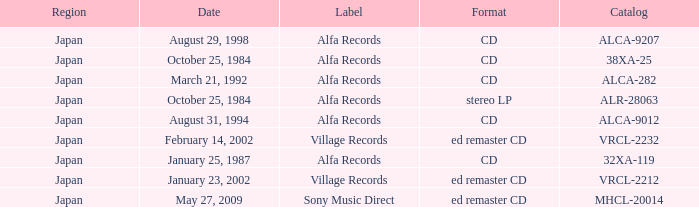What is the region of the release of a CD with catalog 32xa-119? Japan. 